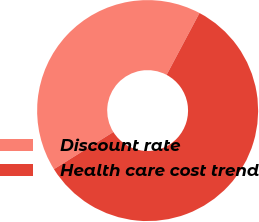<chart> <loc_0><loc_0><loc_500><loc_500><pie_chart><fcel>Discount rate<fcel>Health care cost trend<nl><fcel>41.67%<fcel>58.33%<nl></chart> 